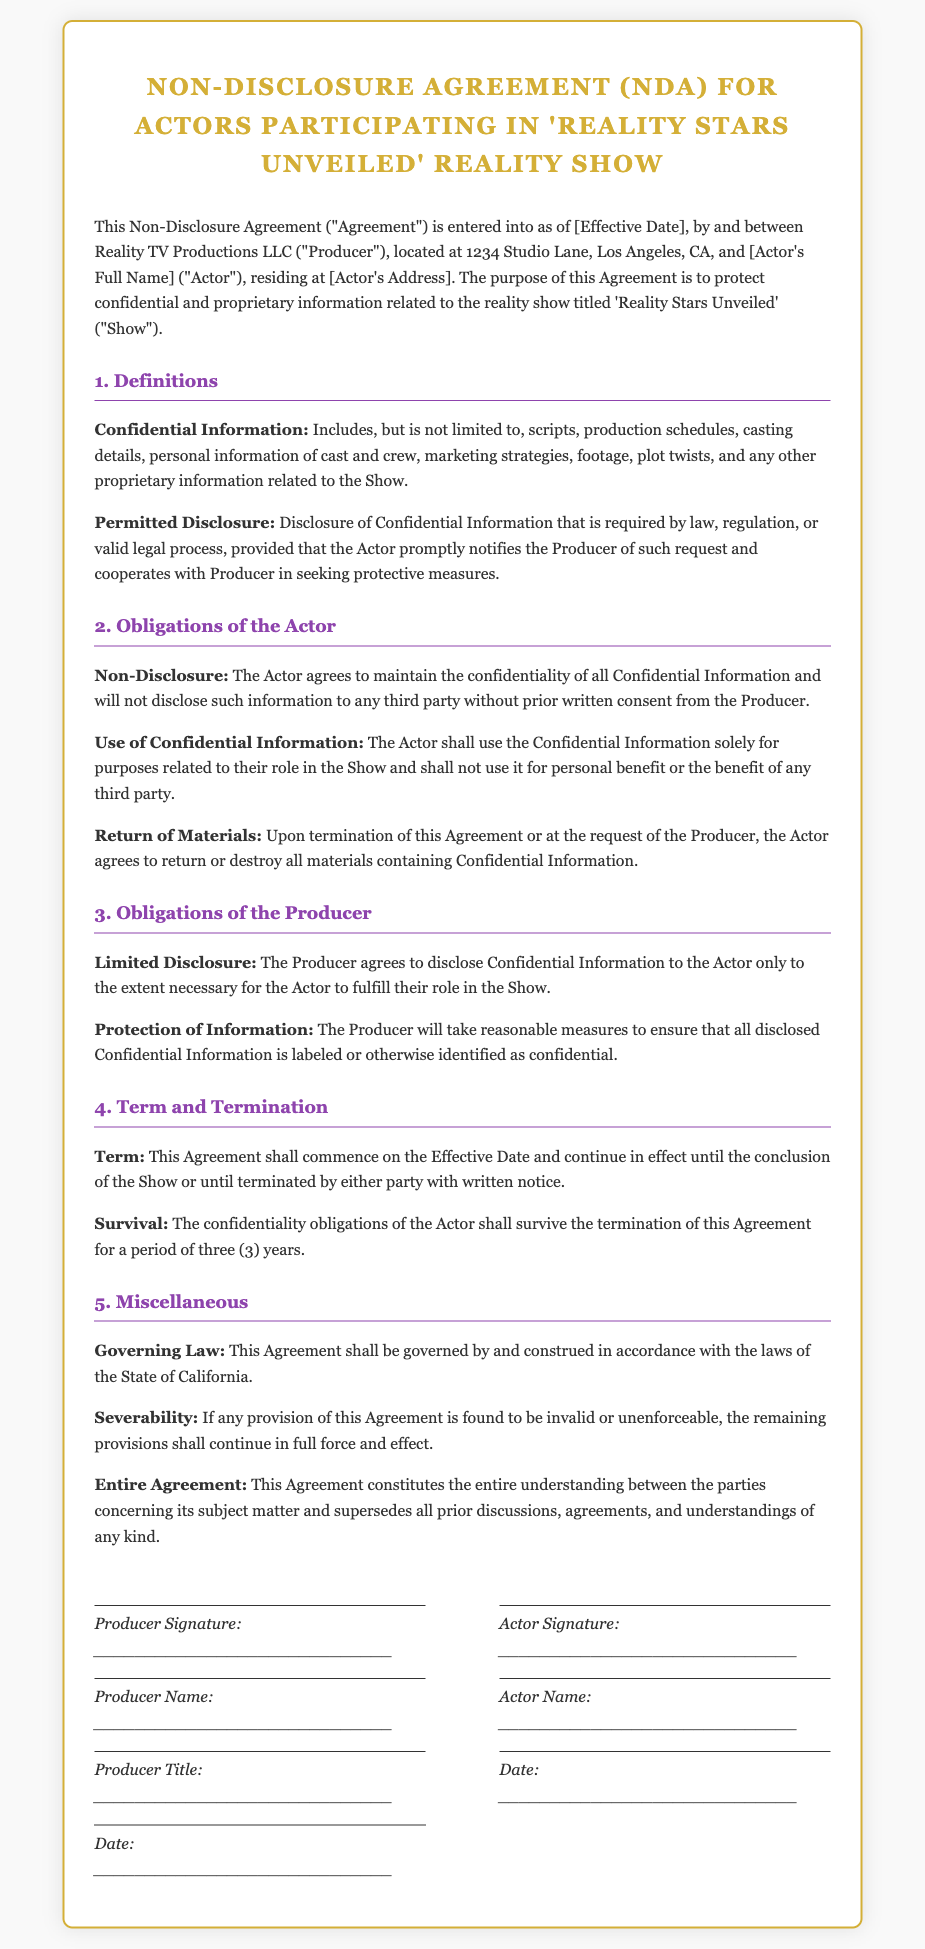What is the title of the document? The title of the document is stated prominently at the top, identifying it as a Non-Disclosure Agreement specifically for the show.
Answer: Non-Disclosure Agreement (NDA) for Actors Participating in 'Reality Stars Unveiled' Reality Show What is defined as Confidential Information? The document specifies what constitutes Confidential Information, including various types of proprietary information.
Answer: Scripts, production schedules, casting details, personal information, marketing strategies, footage, plot twists What is the duration of the Actor's confidentiality obligation after termination? The document clearly outlines the survival of confidentiality obligations after termination.
Answer: Three (3) years Who is responsible for ensuring that disclosed information is labeled as confidential? The document indicates which party has the obligation to protect the confidentiality of the disclosed information.
Answer: Producer What is required for Permitted Disclosure? The document explains the conditions under which Confidential Information may be disclosed legally.
Answer: Required by law, regulation, or valid legal process What must the Actor do with Confidential Information upon request? The document outlines the Actor's obligation regarding the handling of Confidential Information when asked by the Producer.
Answer: Return or destroy all materials containing Confidential Information What is the governing law of the Agreement? The document specifies the jurisdiction that governs the Agreement, which is important for legal interpretation.
Answer: State of California What triggers the termination of this Agreement? The document provides information regarding how either party can terminate the Agreement.
Answer: Written notice 